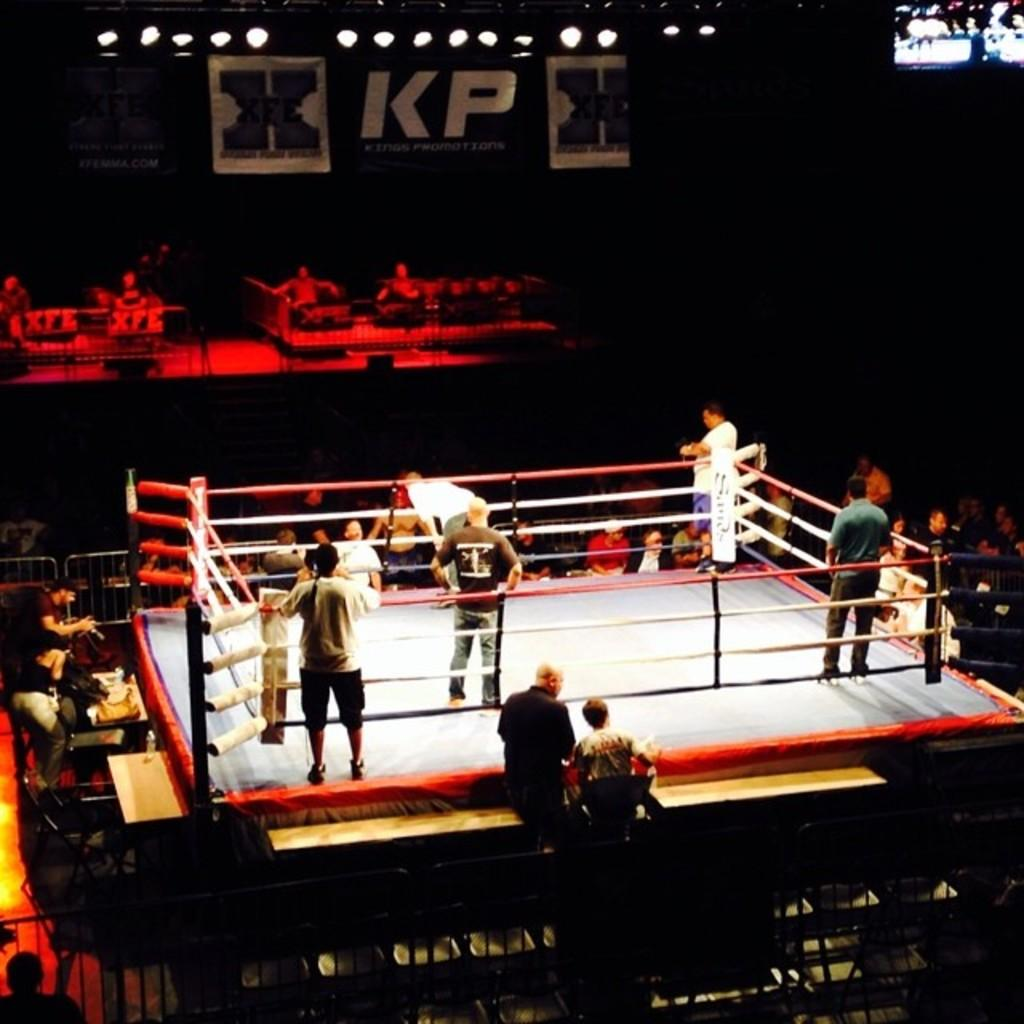<image>
Describe the image concisely. People standing in a boxing ring at a KP event. 